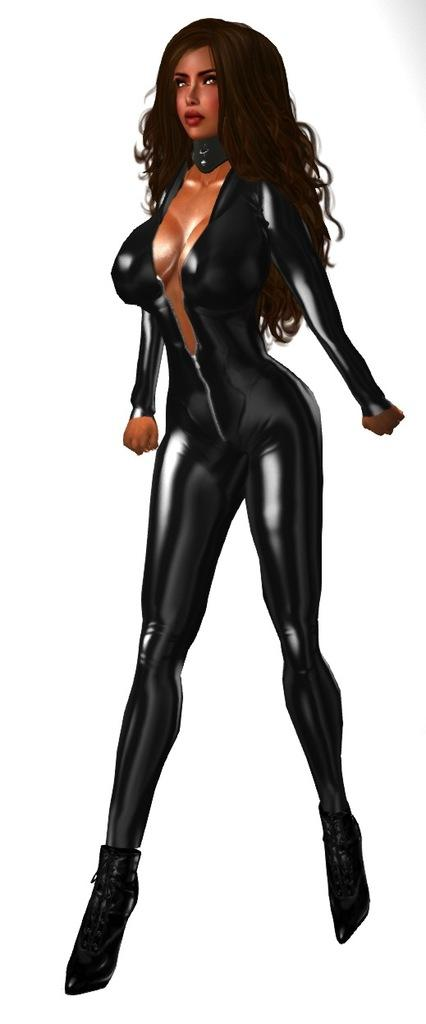What is the main subject of the image? There is an animated picture of a woman in the image. What is the woman doing in the image? The woman is standing. What can be observed about the woman's attire in the image? The woman is wearing clothes. What is the color of the background in the image? The background of the image is white. How many cherries are on the woman's dress in the image? There are no cherries present on the woman's dress in the image. What type of industry is depicted in the background of the image? There is no industry depicted in the background of the image; it is a white background. 